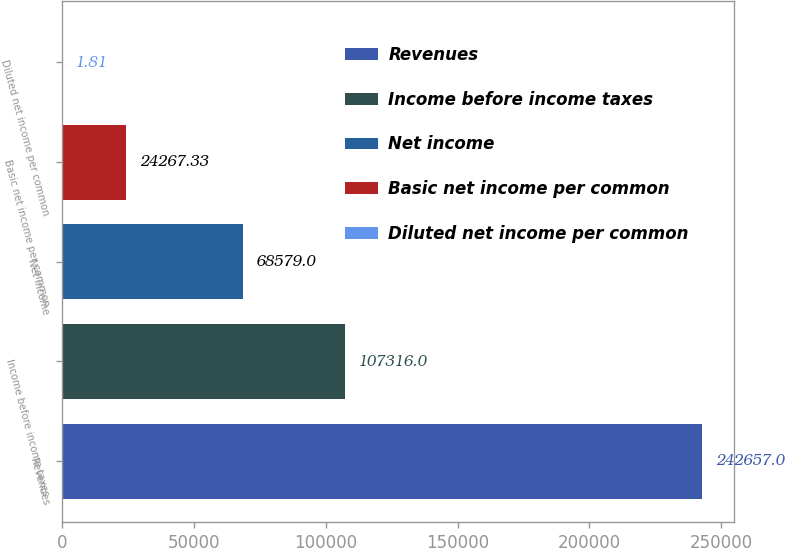Convert chart to OTSL. <chart><loc_0><loc_0><loc_500><loc_500><bar_chart><fcel>Revenues<fcel>Income before income taxes<fcel>Net income<fcel>Basic net income per common<fcel>Diluted net income per common<nl><fcel>242657<fcel>107316<fcel>68579<fcel>24267.3<fcel>1.81<nl></chart> 